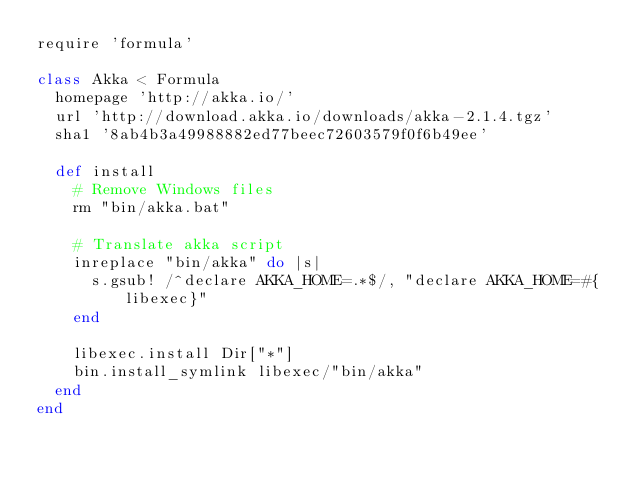<code> <loc_0><loc_0><loc_500><loc_500><_Ruby_>require 'formula'

class Akka < Formula
  homepage 'http://akka.io/'
  url 'http://download.akka.io/downloads/akka-2.1.4.tgz'
  sha1 '8ab4b3a49988882ed77beec72603579f0f6b49ee'

  def install
    # Remove Windows files
    rm "bin/akka.bat"

    # Translate akka script
    inreplace "bin/akka" do |s|
      s.gsub! /^declare AKKA_HOME=.*$/, "declare AKKA_HOME=#{libexec}"
    end

    libexec.install Dir["*"]
    bin.install_symlink libexec/"bin/akka"
  end
end
</code> 